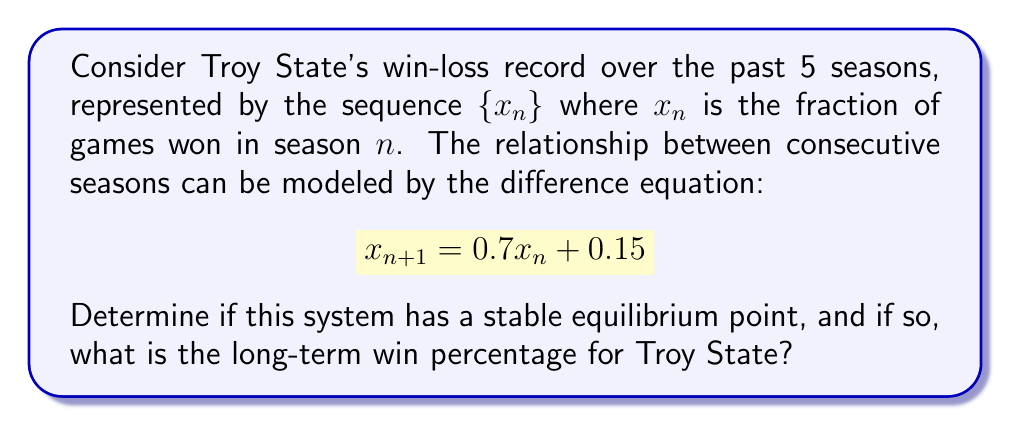Could you help me with this problem? 1) First, we need to find the equilibrium point. At equilibrium, $x_{n+1} = x_n = x^*$. So:

   $$x^* = 0.7x^* + 0.15$$

2) Solve for $x^*$:
   $$x^* - 0.7x^* = 0.15$$
   $$0.3x^* = 0.15$$
   $$x^* = 0.5$$

3) To determine stability, we look at the coefficient of $x_n$ in the original equation. Let's call this $a$:

   $$a = 0.7$$

4) For a linear first-order difference equation of the form $x_{n+1} = ax_n + b$, the equilibrium is stable if $|a| < 1$.

5) In this case, $|0.7| < 1$, so the equilibrium is stable.

6) The stable equilibrium point $x^* = 0.5$ represents a long-term win percentage of 50%.
Answer: Stable equilibrium at 50% win rate 